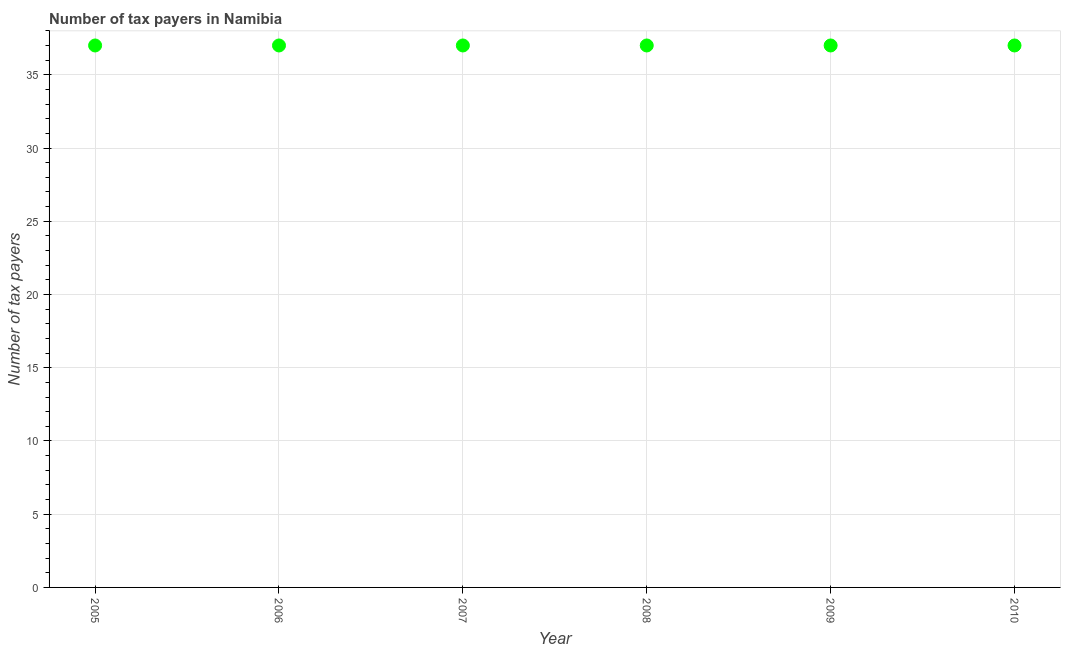What is the number of tax payers in 2009?
Your response must be concise. 37. Across all years, what is the maximum number of tax payers?
Your response must be concise. 37. Across all years, what is the minimum number of tax payers?
Offer a terse response. 37. What is the sum of the number of tax payers?
Your response must be concise. 222. What is the difference between the number of tax payers in 2005 and 2006?
Provide a succinct answer. 0. Do a majority of the years between 2009 and 2005 (inclusive) have number of tax payers greater than 4 ?
Provide a short and direct response. Yes. What is the ratio of the number of tax payers in 2007 to that in 2010?
Keep it short and to the point. 1. Is the difference between the number of tax payers in 2005 and 2008 greater than the difference between any two years?
Your answer should be very brief. Yes. What is the difference between the highest and the second highest number of tax payers?
Provide a short and direct response. 0. What is the difference between the highest and the lowest number of tax payers?
Make the answer very short. 0. In how many years, is the number of tax payers greater than the average number of tax payers taken over all years?
Offer a terse response. 0. Does the number of tax payers monotonically increase over the years?
Your response must be concise. No. How many dotlines are there?
Your response must be concise. 1. How many years are there in the graph?
Offer a terse response. 6. What is the difference between two consecutive major ticks on the Y-axis?
Provide a succinct answer. 5. Does the graph contain any zero values?
Make the answer very short. No. Does the graph contain grids?
Offer a very short reply. Yes. What is the title of the graph?
Keep it short and to the point. Number of tax payers in Namibia. What is the label or title of the Y-axis?
Your answer should be compact. Number of tax payers. What is the Number of tax payers in 2006?
Provide a short and direct response. 37. What is the Number of tax payers in 2009?
Provide a succinct answer. 37. What is the Number of tax payers in 2010?
Provide a succinct answer. 37. What is the difference between the Number of tax payers in 2005 and 2006?
Your answer should be very brief. 0. What is the difference between the Number of tax payers in 2005 and 2007?
Your answer should be very brief. 0. What is the difference between the Number of tax payers in 2006 and 2007?
Your response must be concise. 0. What is the difference between the Number of tax payers in 2006 and 2008?
Offer a very short reply. 0. What is the difference between the Number of tax payers in 2006 and 2009?
Your answer should be compact. 0. What is the difference between the Number of tax payers in 2006 and 2010?
Your response must be concise. 0. What is the difference between the Number of tax payers in 2007 and 2009?
Give a very brief answer. 0. What is the difference between the Number of tax payers in 2007 and 2010?
Provide a succinct answer. 0. What is the difference between the Number of tax payers in 2009 and 2010?
Offer a terse response. 0. What is the ratio of the Number of tax payers in 2005 to that in 2008?
Ensure brevity in your answer.  1. What is the ratio of the Number of tax payers in 2005 to that in 2010?
Give a very brief answer. 1. What is the ratio of the Number of tax payers in 2006 to that in 2008?
Offer a very short reply. 1. What is the ratio of the Number of tax payers in 2006 to that in 2009?
Make the answer very short. 1. What is the ratio of the Number of tax payers in 2007 to that in 2008?
Keep it short and to the point. 1. What is the ratio of the Number of tax payers in 2008 to that in 2009?
Your answer should be very brief. 1. What is the ratio of the Number of tax payers in 2008 to that in 2010?
Your answer should be compact. 1. What is the ratio of the Number of tax payers in 2009 to that in 2010?
Your answer should be very brief. 1. 